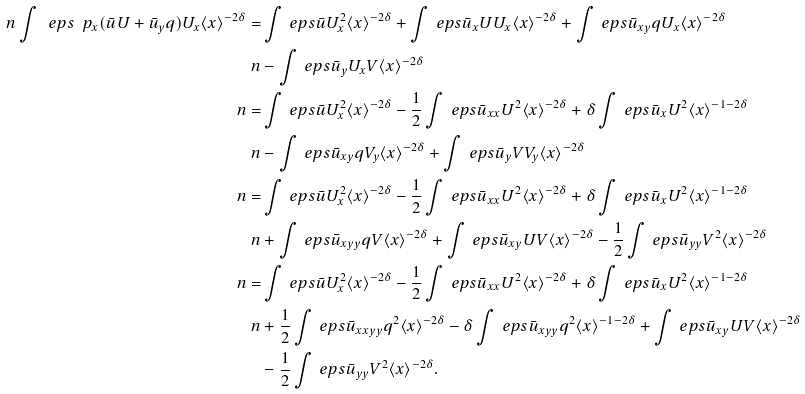Convert formula to latex. <formula><loc_0><loc_0><loc_500><loc_500>\ n \int \ e p s \ p _ { x } ( \bar { u } U + \bar { u } _ { y } q ) U _ { x } \langle x \rangle ^ { - 2 \delta } = & \int \ e p s \bar { u } U _ { x } ^ { 2 } \langle x \rangle ^ { - 2 \delta } + \int \ e p s \bar { u } _ { x } U U _ { x } \langle x \rangle ^ { - 2 \delta } + \int \ e p s \bar { u } _ { x y } q U _ { x } \langle x \rangle ^ { - 2 \delta } \\ \ n & - \int \ e p s \bar { u } _ { y } U _ { x } V \langle x \rangle ^ { - 2 \delta } \\ \ n = & \int \ e p s \bar { u } U _ { x } ^ { 2 } \langle x \rangle ^ { - 2 \delta } - \frac { 1 } { 2 } \int \ e p s \bar { u } _ { x x } U ^ { 2 } \langle x \rangle ^ { - 2 \delta } + \delta \int \ e p s \bar { u } _ { x } U ^ { 2 } \langle x \rangle ^ { - 1 - 2 \delta } \\ \ n & - \int \ e p s \bar { u } _ { x y } q V _ { y } \langle x \rangle ^ { - 2 \delta } + \int \ e p s \bar { u } _ { y } V V _ { y } \langle x \rangle ^ { - 2 \delta } \\ \ n = & \int \ e p s \bar { u } U _ { x } ^ { 2 } \langle x \rangle ^ { - 2 \delta } - \frac { 1 } { 2 } \int \ e p s \bar { u } _ { x x } U ^ { 2 } \langle x \rangle ^ { - 2 \delta } + \delta \int \ e p s \bar { u } _ { x } U ^ { 2 } \langle x \rangle ^ { - 1 - 2 \delta } \\ \ n & + \int \ e p s \bar { u } _ { x y y } q V \langle x \rangle ^ { - 2 \delta } + \int \ e p s \bar { u } _ { x y } U V \langle x \rangle ^ { - 2 \delta } - \frac { 1 } { 2 } \int \ e p s \bar { u } _ { y y } V ^ { 2 } \langle x \rangle ^ { - 2 \delta } \\ \ n = & \int \ e p s \bar { u } U _ { x } ^ { 2 } \langle x \rangle ^ { - 2 \delta } - \frac { 1 } { 2 } \int \ e p s \bar { u } _ { x x } U ^ { 2 } \langle x \rangle ^ { - 2 \delta } + \delta \int \ e p s \bar { u } _ { x } U ^ { 2 } \langle x \rangle ^ { - 1 - 2 \delta } \\ \ n & + \frac { 1 } { 2 } \int \ e p s \bar { u } _ { x x y y } q ^ { 2 } \langle x \rangle ^ { - 2 \delta } - \delta \int \ e p s \bar { u } _ { x y y } q ^ { 2 } \langle x \rangle ^ { - 1 - 2 \delta } + \int \ e p s \bar { u } _ { x y } U V \langle x \rangle ^ { - 2 \delta } \\ & - \frac { 1 } { 2 } \int \ e p s \bar { u } _ { y y } V ^ { 2 } \langle x \rangle ^ { - 2 \delta } .</formula> 